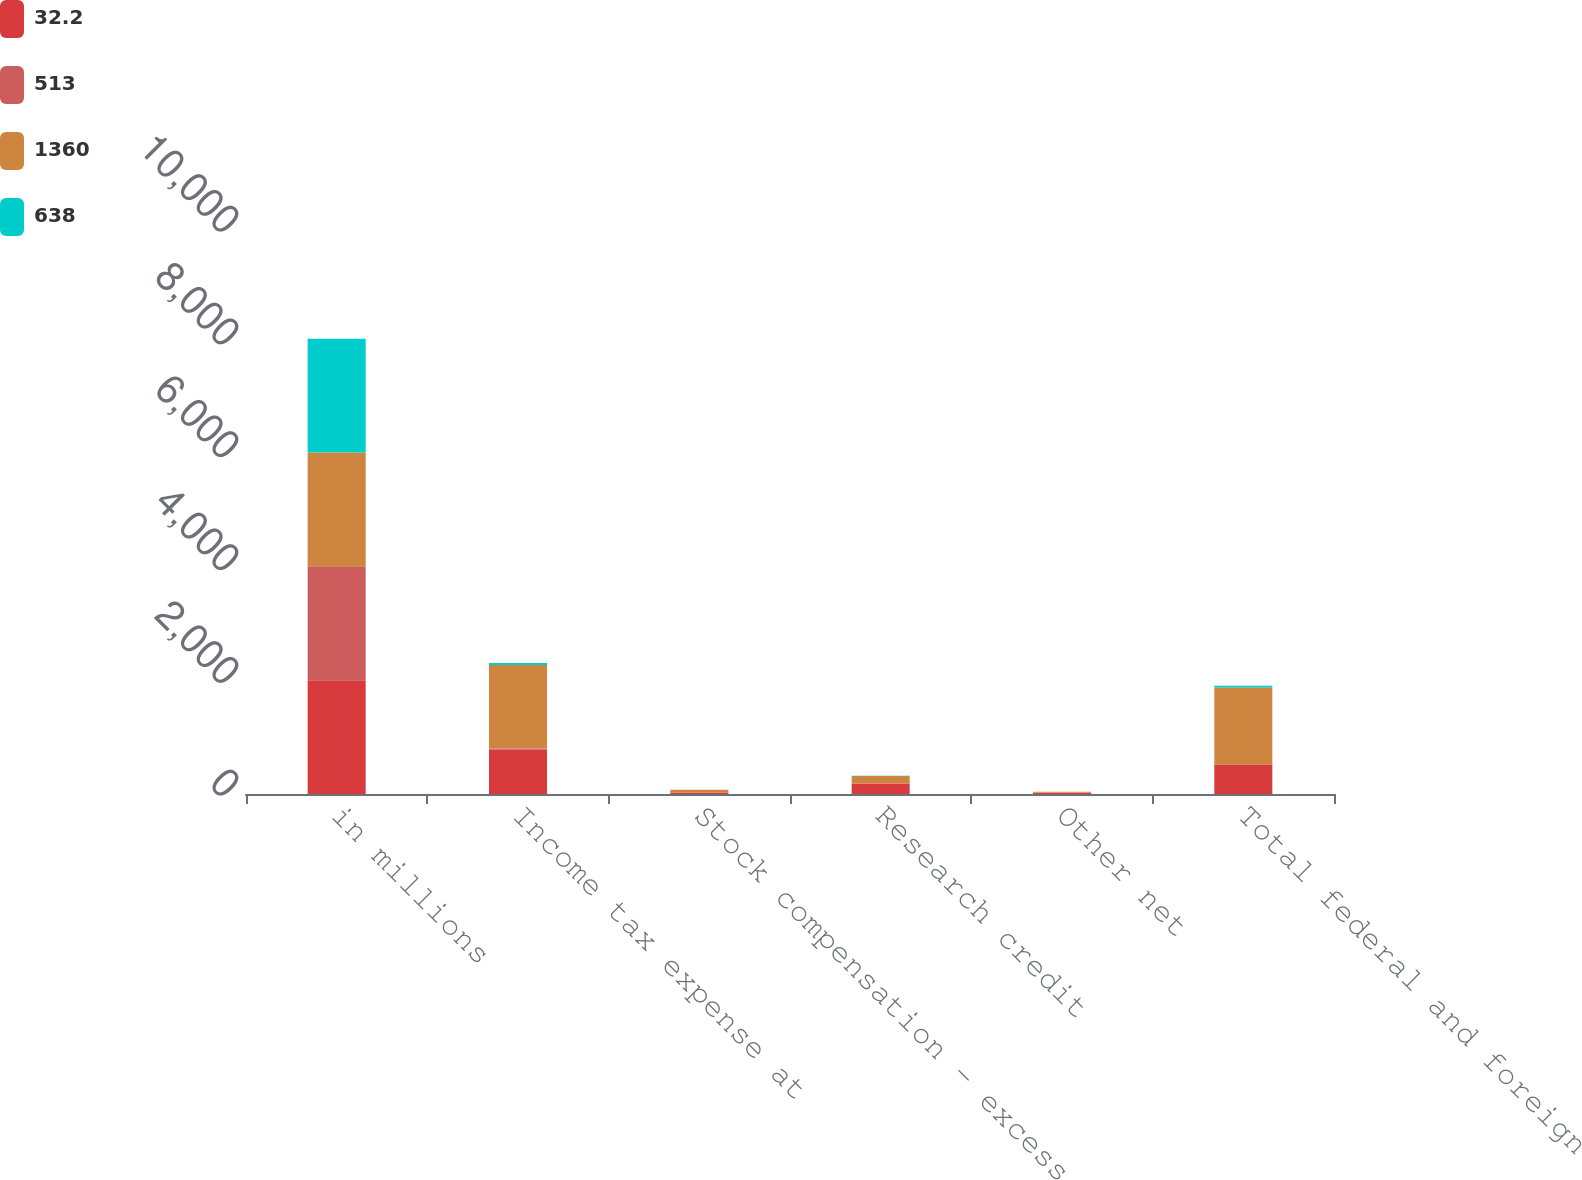Convert chart. <chart><loc_0><loc_0><loc_500><loc_500><stacked_bar_chart><ecel><fcel>in millions<fcel>Income tax expense at<fcel>Stock compensation - excess<fcel>Research credit<fcel>Other net<fcel>Total federal and foreign<nl><fcel>32.2<fcel>2018<fcel>786<fcel>27<fcel>186<fcel>24<fcel>513<nl><fcel>513<fcel>2018<fcel>21<fcel>0.7<fcel>5<fcel>0.6<fcel>13.7<nl><fcel>1360<fcel>2017<fcel>1480<fcel>48<fcel>130<fcel>16<fcel>1360<nl><fcel>638<fcel>2017<fcel>35<fcel>1.1<fcel>3.1<fcel>0.4<fcel>32.2<nl></chart> 